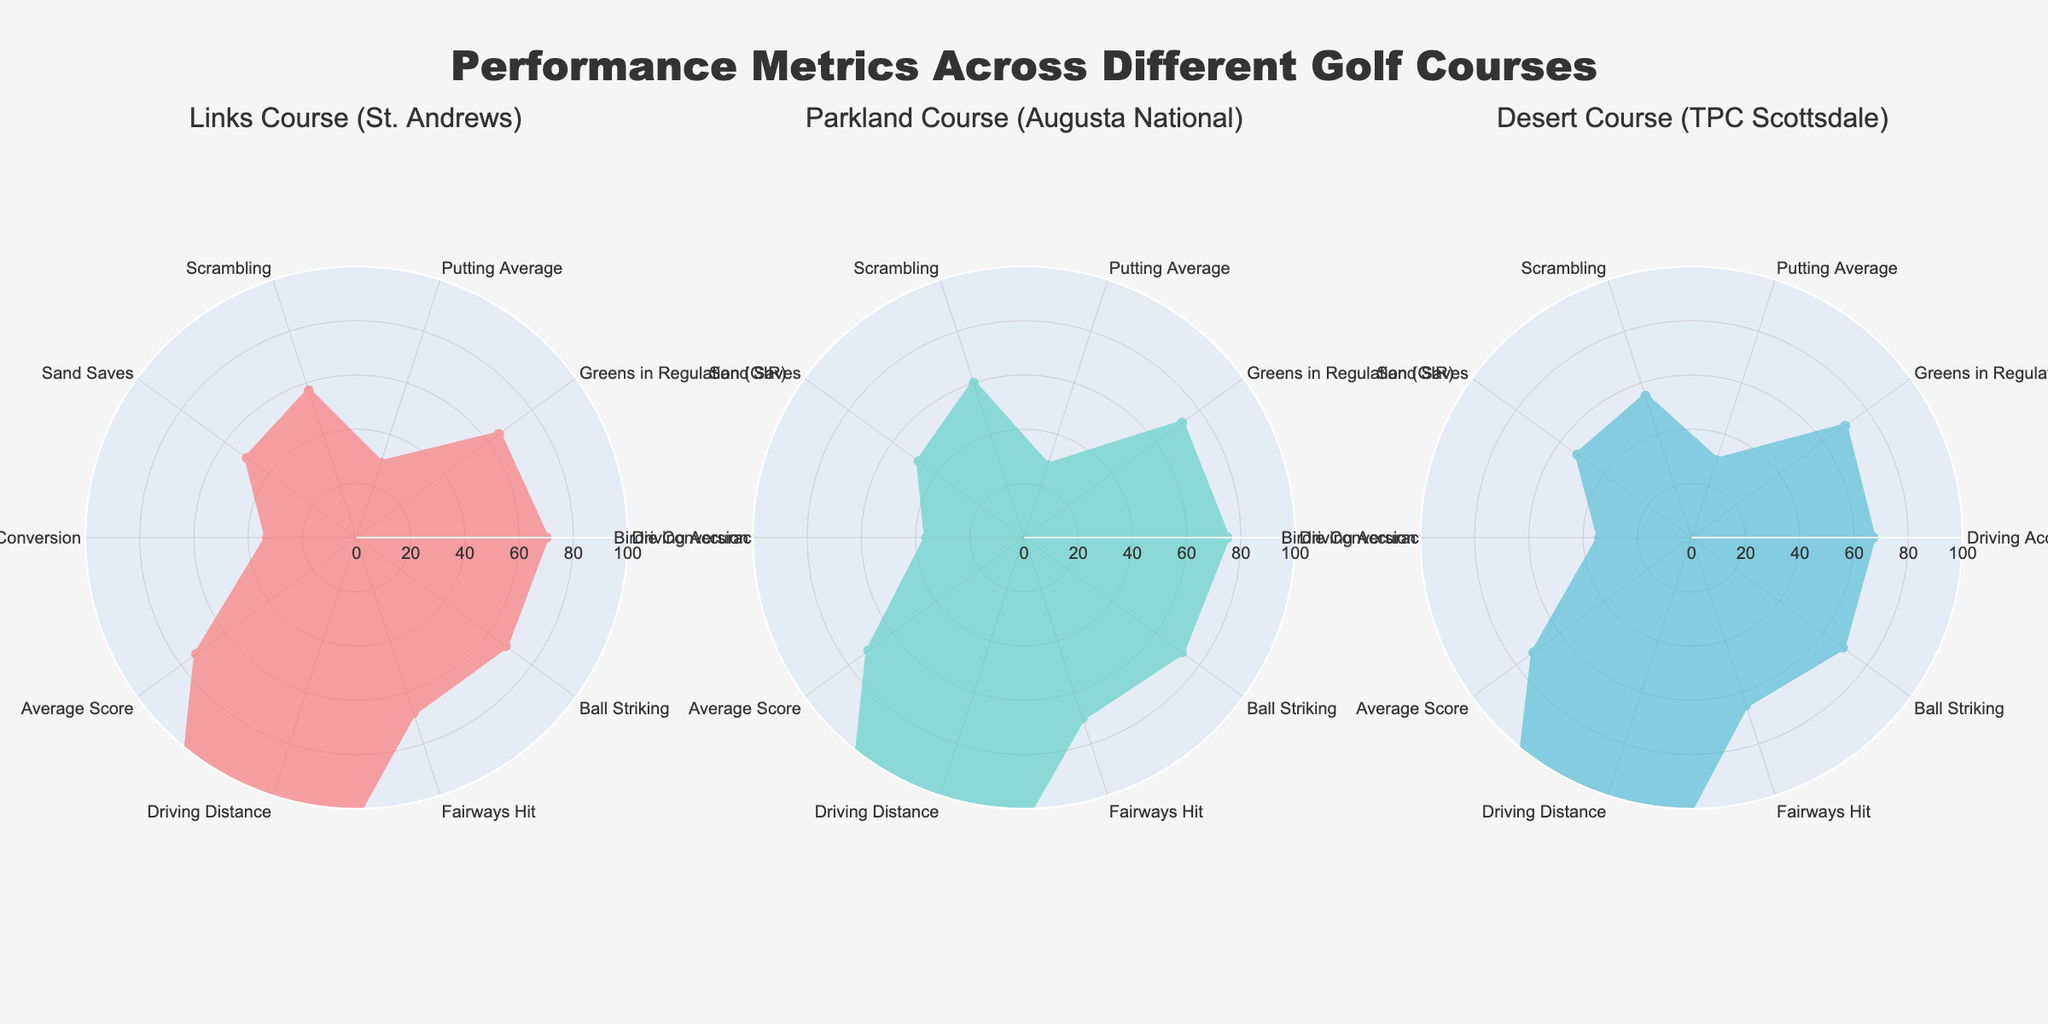What is the title of the figure? The title of the figure is mentioned at the top in a larger font size, placed centrally. It reads "Performance Metrics Across Different Golf Courses".
Answer: Performance Metrics Across Different Golf Courses Which course has the highest Driving Distance? Driving Distance is compared across the three courses: St. Andrews (260), Augusta National (255), and TPC Scottsdale (270). TPC Scottsdale clearly has the highest value.
Answer: TPC Scottsdale Which metric has the smallest difference across all three courses? By examining each metric's values for all three courses: Driving Accuracy (70, 75, 67), Greens in Regulation (65, 72, 70), Scrambling (57, 60, 55), etc., Putting Average (29, 28, 30) shows the smallest range of values.
Answer: Putting Average What is the average Greens in Regulation (GIR) across all three courses? The Greens in Regulation values are: St. Andrews (65), Augusta National (72), and TPC Scottsdale (70). Summing these up (65 + 72 + 70) gives 207. Dividing by 3 to find the average: 207/3 = 69.
Answer: 69 Which course has the best Birdie Conversion rate? Birdie Conversion rates are: St. Andrews (33), Augusta National (36), and TPC Scottsdale (34). The highest value among these is at Augusta National.
Answer: Augusta National Which type of course has the lowest Scrambling rate? Scrambling rates are compared: St. Andrews (57), Augusta National (60), TPC Scottsdale (55). TPC Scottsdale has the lowest value.
Answer: TPC Scottsdale By how many points does the Driving Accuracy of Augusta National exceed that of TPC Scottsdale? Driving Accuracy values are: Augusta National (75) and TPC Scottsdale (67). The difference is 75 - 67 = 8 points.
Answer: 8 What is the total of Fairways Hit across the three courses? Fairways Hit values for St. Andrews (68), Augusta National (70), and TPC Scottsdale (65). Summing these up: 68 + 70 + 65 = 203.
Answer: 203 Which metric shows the largest range (difference between highest and lowest values) across all courses? To find the range, we calculate the differences: Driving Accuracy (75-67=8), GIR (72-65=7), etc. The largest range is seen in Driving Distance (270-255=15).
Answer: Driving Distance 